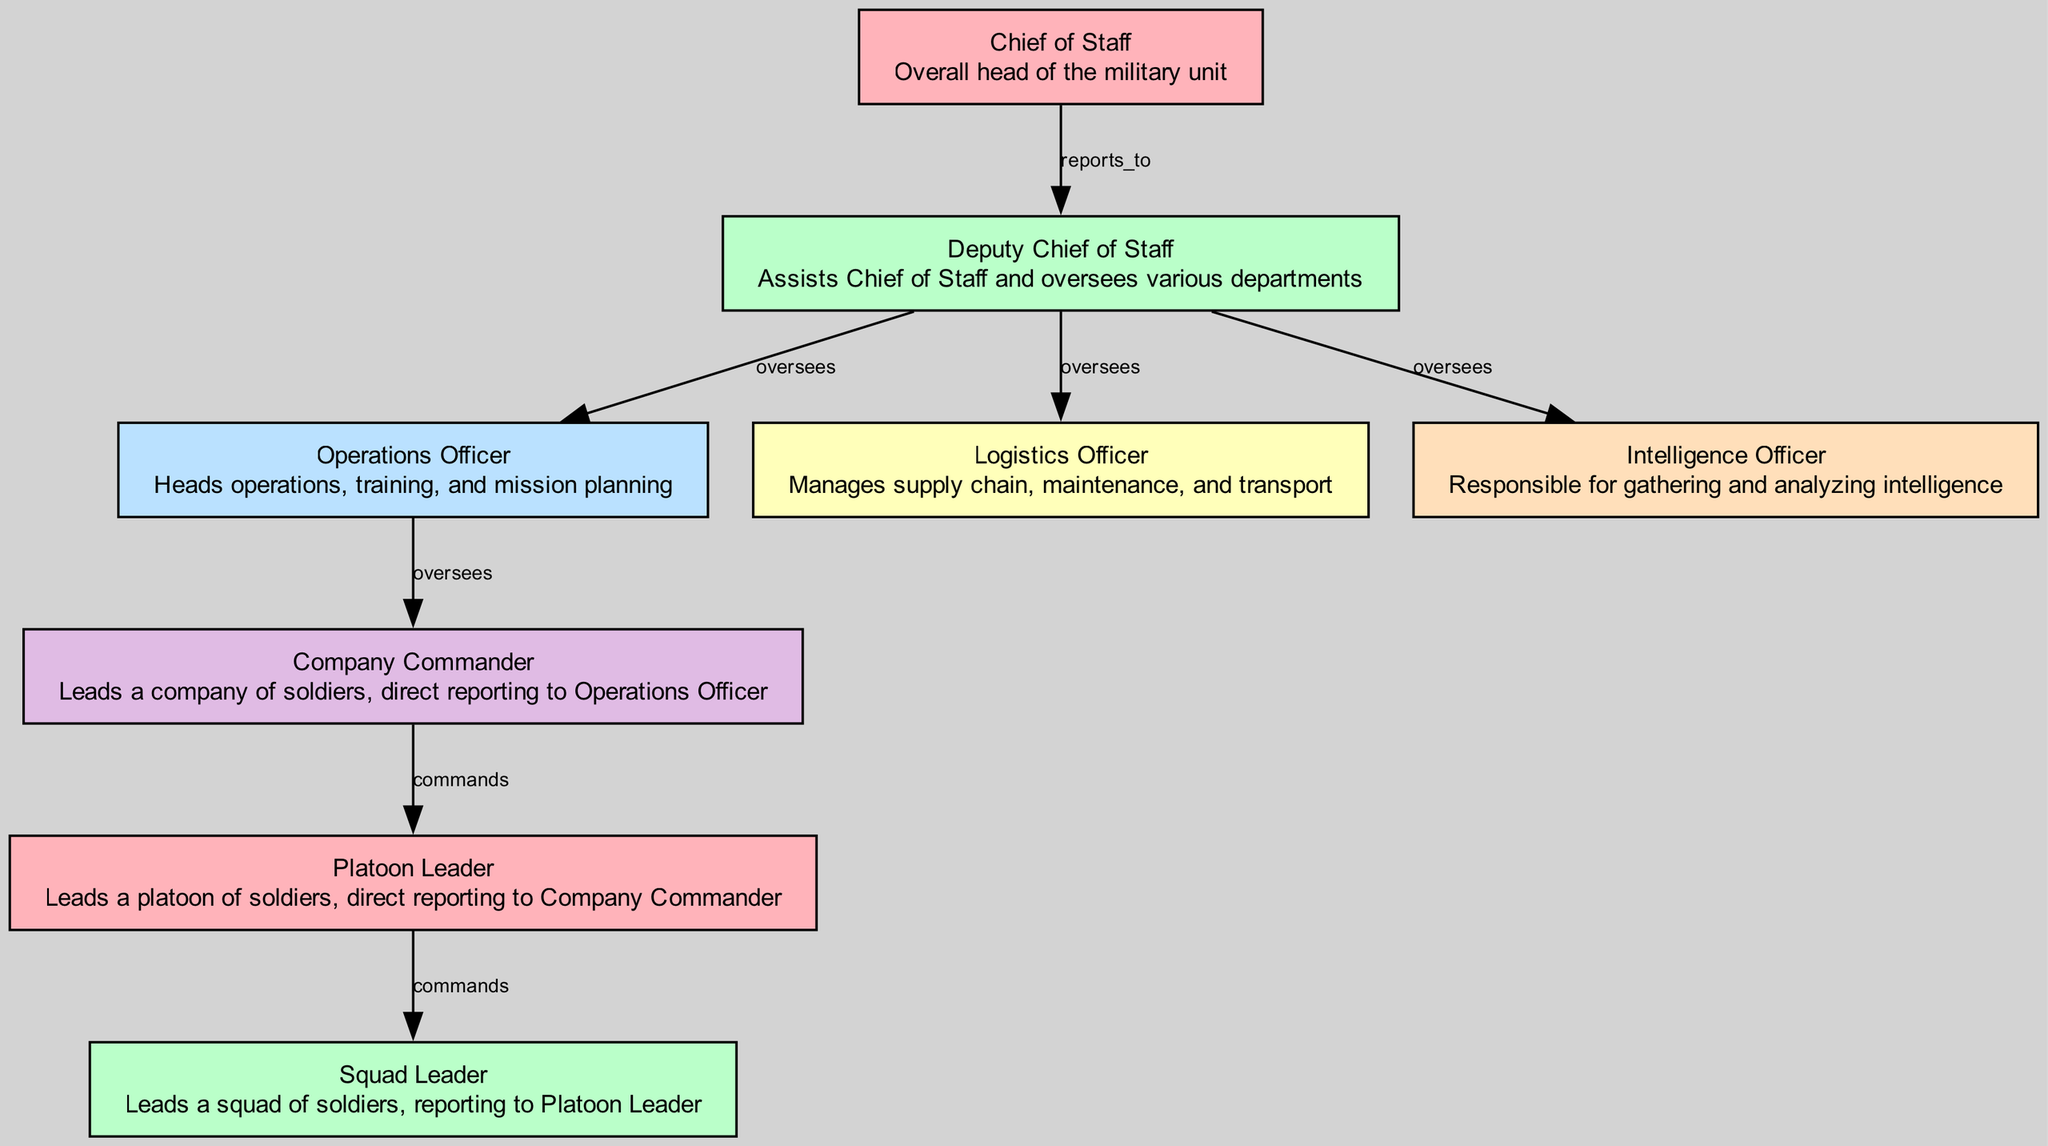What is the top position in the chain of command? The diagram indicates that the top position is "Chief of Staff," which is the overall head of the military unit. The "Chief of Staff" node is placed at the top of the hierarchy.
Answer: Chief of Staff How many nodes are present in the diagram? By counting the nodes represented in the diagram, we find there are eight specific roles listed. The "nodes" section within the data specifies the count of different positions.
Answer: Eight Who does the Deputy Chief of Staff oversee? The "Deputy Chief of Staff" directly oversees the "Operations Officer," "Logistics Officer," and "Intelligence Officer," as shown by the edges connecting from "Deputy Chief of Staff" to these positions.
Answer: Operations Officer, Logistics Officer, Intelligence Officer What is the relationship between the Company Commander and the Platoon Leader? The diagram demonstrates that the "Company Commander" commands the "Platoon Leader," as indicated by the edge showing a direct command relationship.
Answer: Commands Which role reports to the Operations Officer? The "Company Commander" reports to the "Operations Officer" according to the diagram's structure, which highlights the chain of command.
Answer: Company Commander What is the lowest rank in the hierarchy? Examining the diagram, the "Squad Leader" is the lowest rank, as it has the least level of authority and reports to the "Platoon Leader."
Answer: Squad Leader How many edges connect to the Deputy Chief of Staff? By analyzing the connections in the diagram, it is found that there are three edges stemming from the "Deputy Chief of Staff" to the roles of "Operations Officer," "Logistics Officer," and "Intelligence Officer."
Answer: Three What position comes directly after the Platoon Leader? After reviewing the hierarchy, it is clear that the "Squad Leader" directly follows the "Platoon Leader" in the chain of command.
Answer: Squad Leader What is the primary responsibility of the Operations Officer? The description at the "Operations Officer" node states that this role heads operations, training, and mission planning, providing insight into its primary responsibilities.
Answer: Heads operations, training, and mission planning 